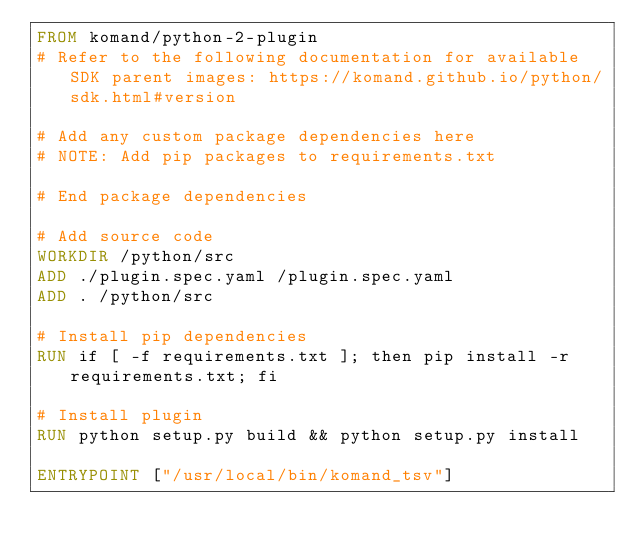<code> <loc_0><loc_0><loc_500><loc_500><_Dockerfile_>FROM komand/python-2-plugin
# Refer to the following documentation for available SDK parent images: https://komand.github.io/python/sdk.html#version

# Add any custom package dependencies here
# NOTE: Add pip packages to requirements.txt

# End package dependencies

# Add source code
WORKDIR /python/src
ADD ./plugin.spec.yaml /plugin.spec.yaml
ADD . /python/src

# Install pip dependencies
RUN if [ -f requirements.txt ]; then pip install -r requirements.txt; fi

# Install plugin
RUN python setup.py build && python setup.py install

ENTRYPOINT ["/usr/local/bin/komand_tsv"]</code> 